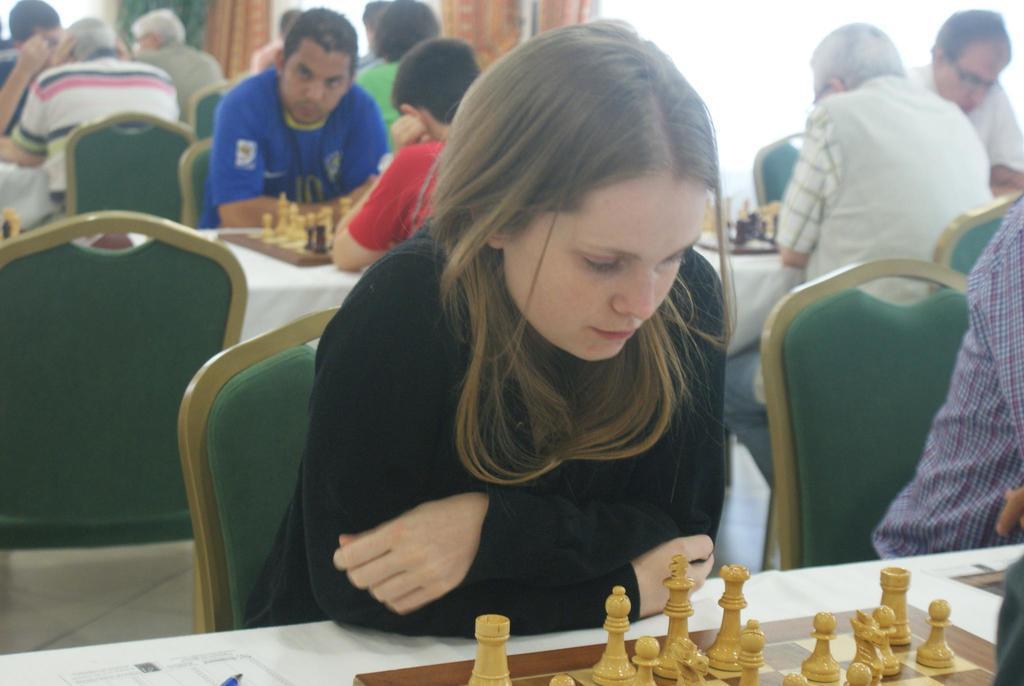Can you describe this image briefly? people are seated on green chairs. in front of them there are white tables on which there are chess boards. a person at the front is playing a black t shirt and playing chess. at the back there are curtains and windows. 